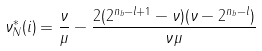Convert formula to latex. <formula><loc_0><loc_0><loc_500><loc_500>\nu ^ { * } _ { N } ( i ) = \frac { \nu } { \mu } - \frac { 2 ( 2 ^ { n _ { b } - l + 1 } - \nu ) ( \nu - 2 ^ { n _ { b } - l } ) } { \nu \mu }</formula> 